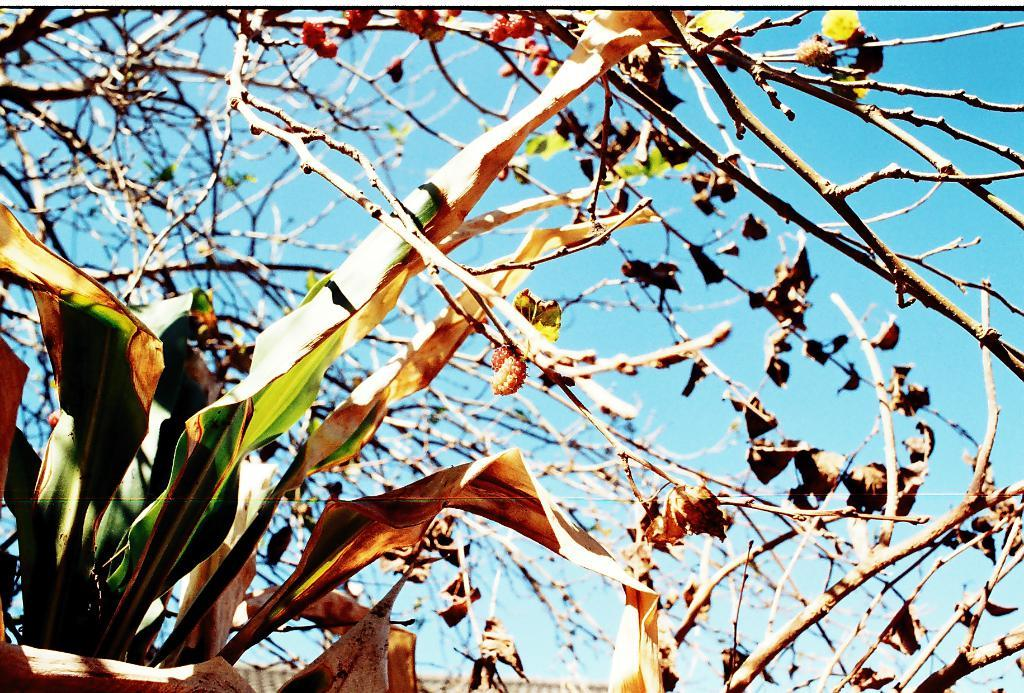What type of vegetation can be seen in the image? There are trees in the image. What is present on the ground beneath the trees? There are dry leaves in the image. What can be seen in the distance in the image? The sky is visible in the background of the image. Where is the kettle located in the image? There is no kettle present in the image. How does the transport system function in the image? There is no transport system depicted in the image. 